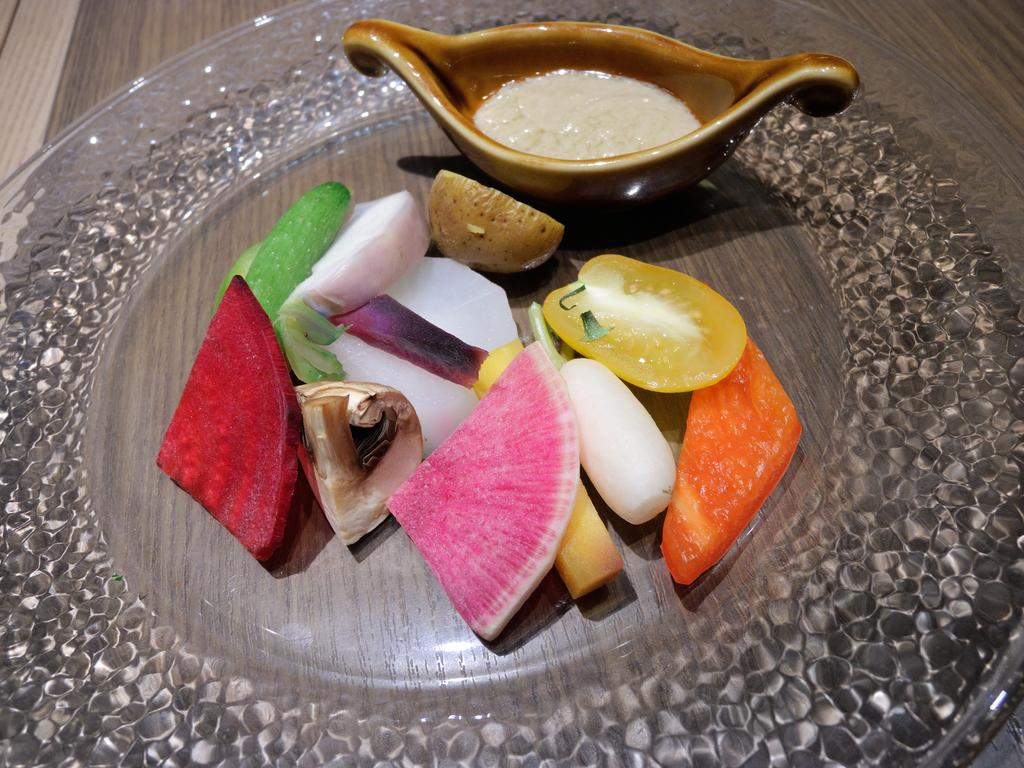What is on the plate that is visible in the image? There is a plate containing food in the image. What other dish can be seen in the image besides the plate? There is a bowl at the top of the image. How many mice are running around the plate in the image? There are no mice present in the image. What direction is the activity in the image taking place? The image does not depict any activity or direction; it only shows a plate with food and a bowl. 